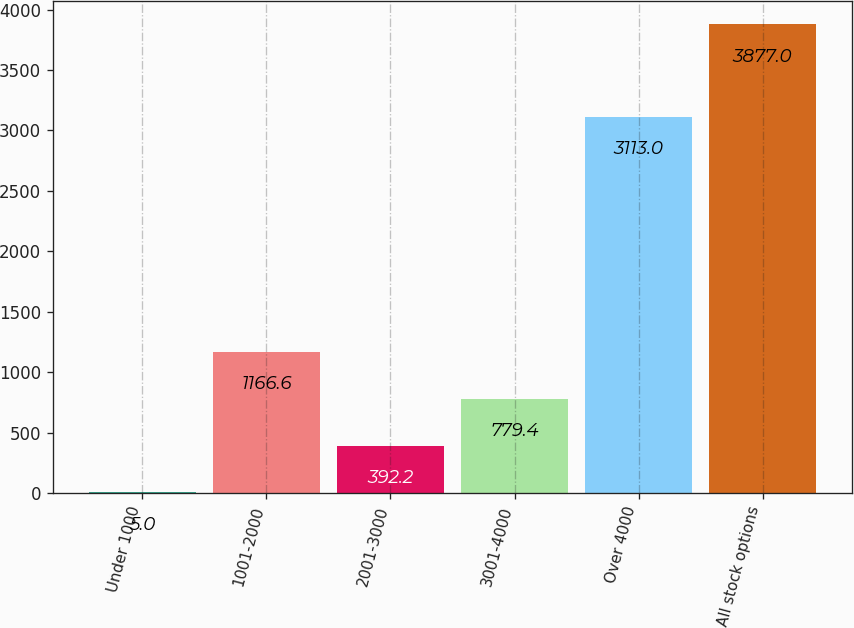Convert chart to OTSL. <chart><loc_0><loc_0><loc_500><loc_500><bar_chart><fcel>Under 1000<fcel>1001-2000<fcel>2001-3000<fcel>3001-4000<fcel>Over 4000<fcel>All stock options<nl><fcel>5<fcel>1166.6<fcel>392.2<fcel>779.4<fcel>3113<fcel>3877<nl></chart> 